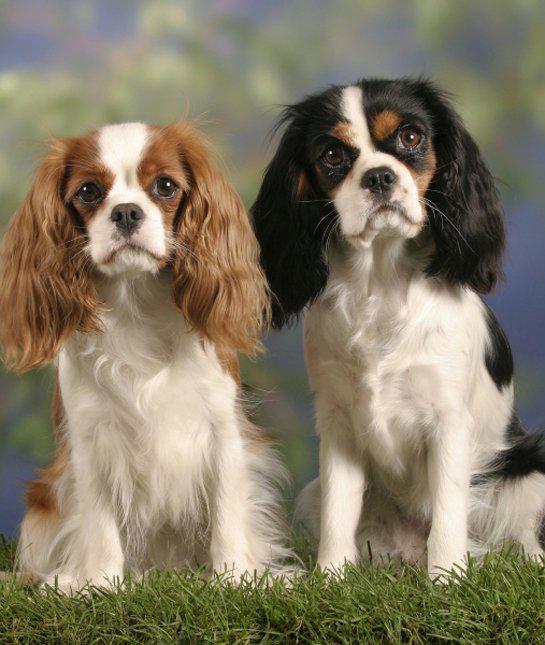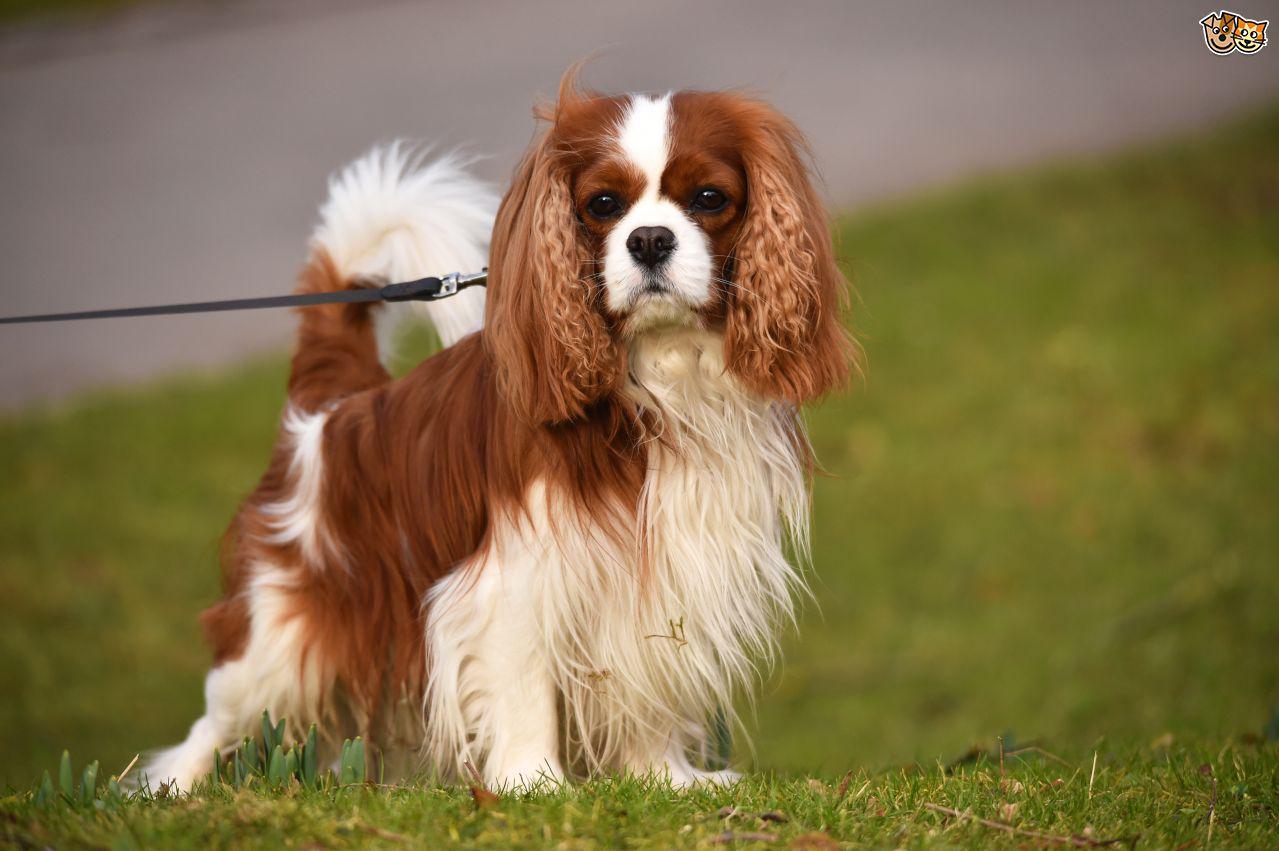The first image is the image on the left, the second image is the image on the right. Considering the images on both sides, is "there are three animals." valid? Answer yes or no. Yes. The first image is the image on the left, the second image is the image on the right. Evaluate the accuracy of this statement regarding the images: "There are no more than two animals". Is it true? Answer yes or no. No. 